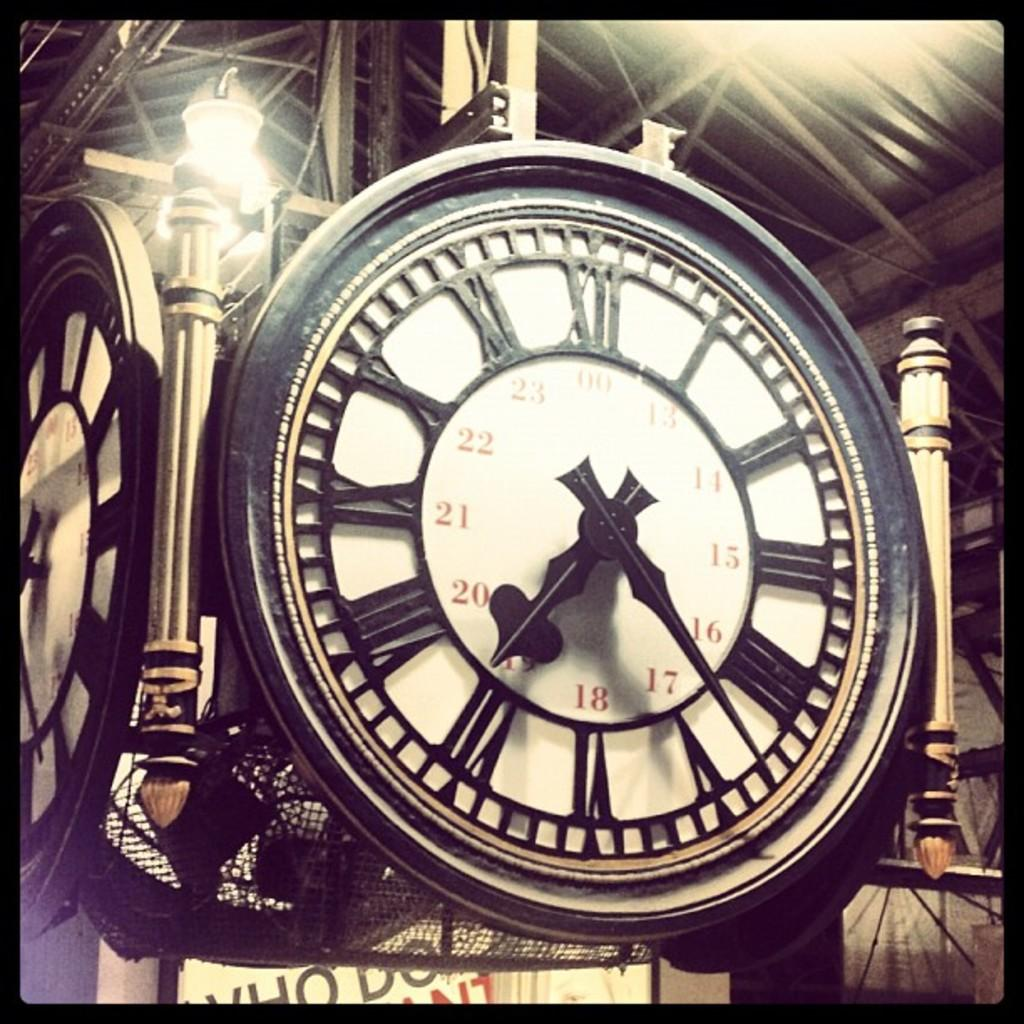<image>
Present a compact description of the photo's key features. A clock features roman numerals, as well as th enumbers 00, 13, 14, 15, 16, 17, 18, 19, 20, 21, 22, and 23. 